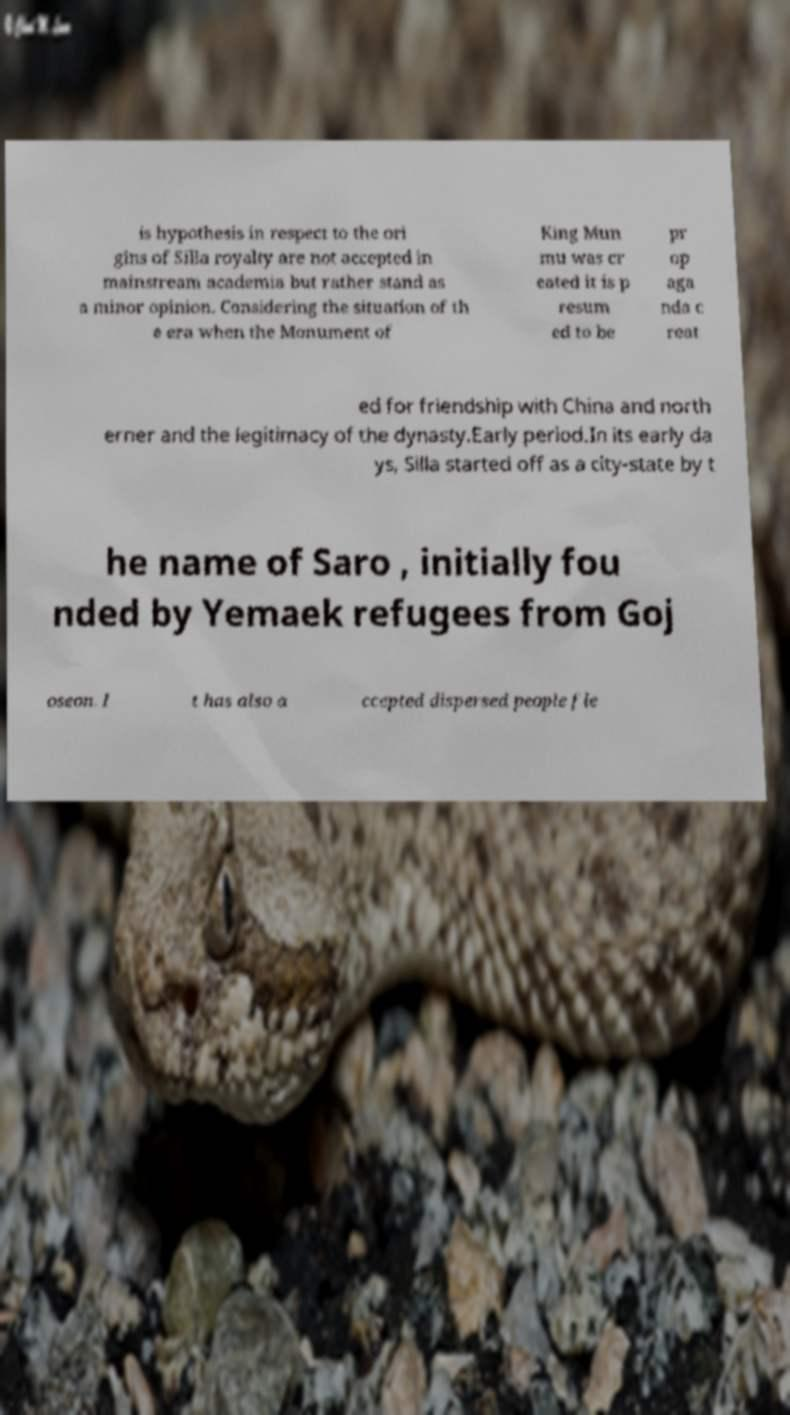Can you read and provide the text displayed in the image?This photo seems to have some interesting text. Can you extract and type it out for me? is hypothesis in respect to the ori gins of Silla royalty are not accepted in mainstream academia but rather stand as a minor opinion. Considering the situation of th e era when the Monument of King Mun mu was cr eated it is p resum ed to be pr op aga nda c reat ed for friendship with China and north erner and the legitimacy of the dynasty.Early period.In its early da ys, Silla started off as a city-state by t he name of Saro , initially fou nded by Yemaek refugees from Goj oseon. I t has also a ccepted dispersed people fle 